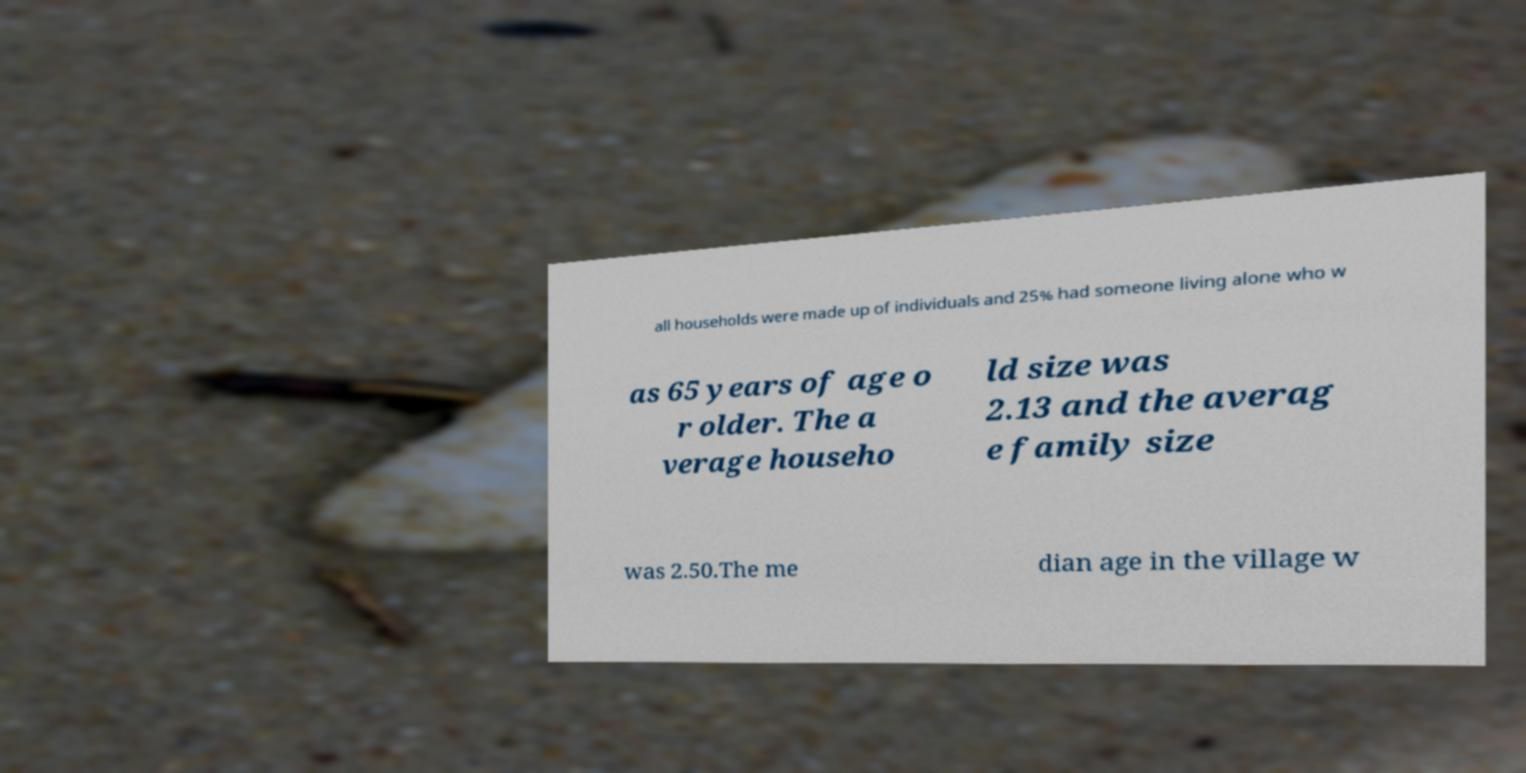Could you extract and type out the text from this image? all households were made up of individuals and 25% had someone living alone who w as 65 years of age o r older. The a verage househo ld size was 2.13 and the averag e family size was 2.50.The me dian age in the village w 